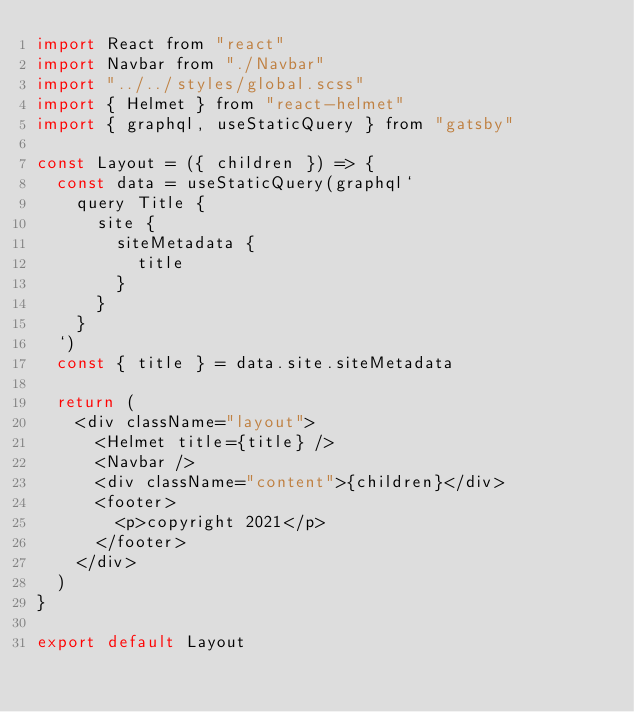Convert code to text. <code><loc_0><loc_0><loc_500><loc_500><_JavaScript_>import React from "react"
import Navbar from "./Navbar"
import "../../styles/global.scss"
import { Helmet } from "react-helmet"
import { graphql, useStaticQuery } from "gatsby"

const Layout = ({ children }) => {
  const data = useStaticQuery(graphql`
    query Title {
      site {
        siteMetadata {
          title
        }
      }
    }
  `)
  const { title } = data.site.siteMetadata

  return (
    <div className="layout">
      <Helmet title={title} />
      <Navbar />
      <div className="content">{children}</div>
      <footer>
        <p>copyright 2021</p>
      </footer>
    </div>
  )
}

export default Layout
</code> 